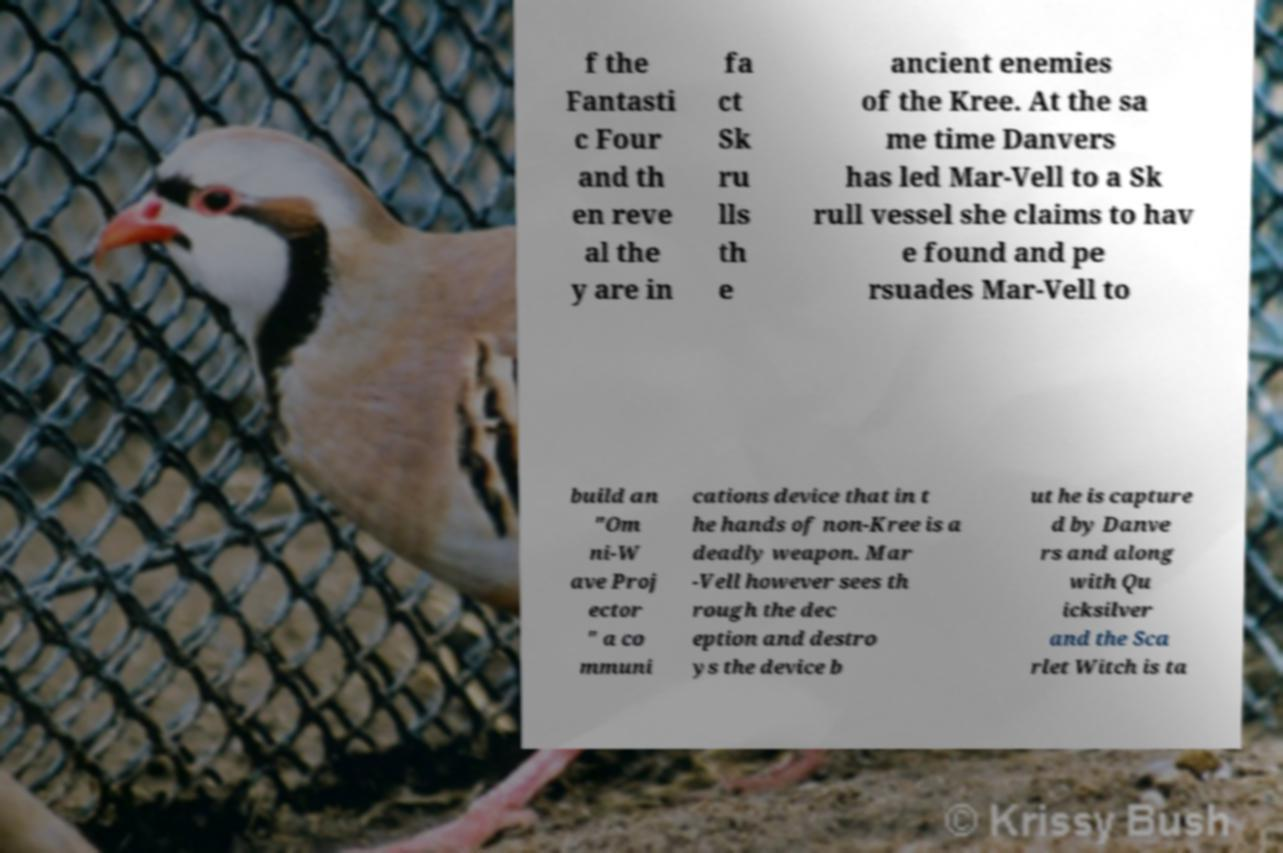There's text embedded in this image that I need extracted. Can you transcribe it verbatim? f the Fantasti c Four and th en reve al the y are in fa ct Sk ru lls th e ancient enemies of the Kree. At the sa me time Danvers has led Mar-Vell to a Sk rull vessel she claims to hav e found and pe rsuades Mar-Vell to build an "Om ni-W ave Proj ector " a co mmuni cations device that in t he hands of non-Kree is a deadly weapon. Mar -Vell however sees th rough the dec eption and destro ys the device b ut he is capture d by Danve rs and along with Qu icksilver and the Sca rlet Witch is ta 